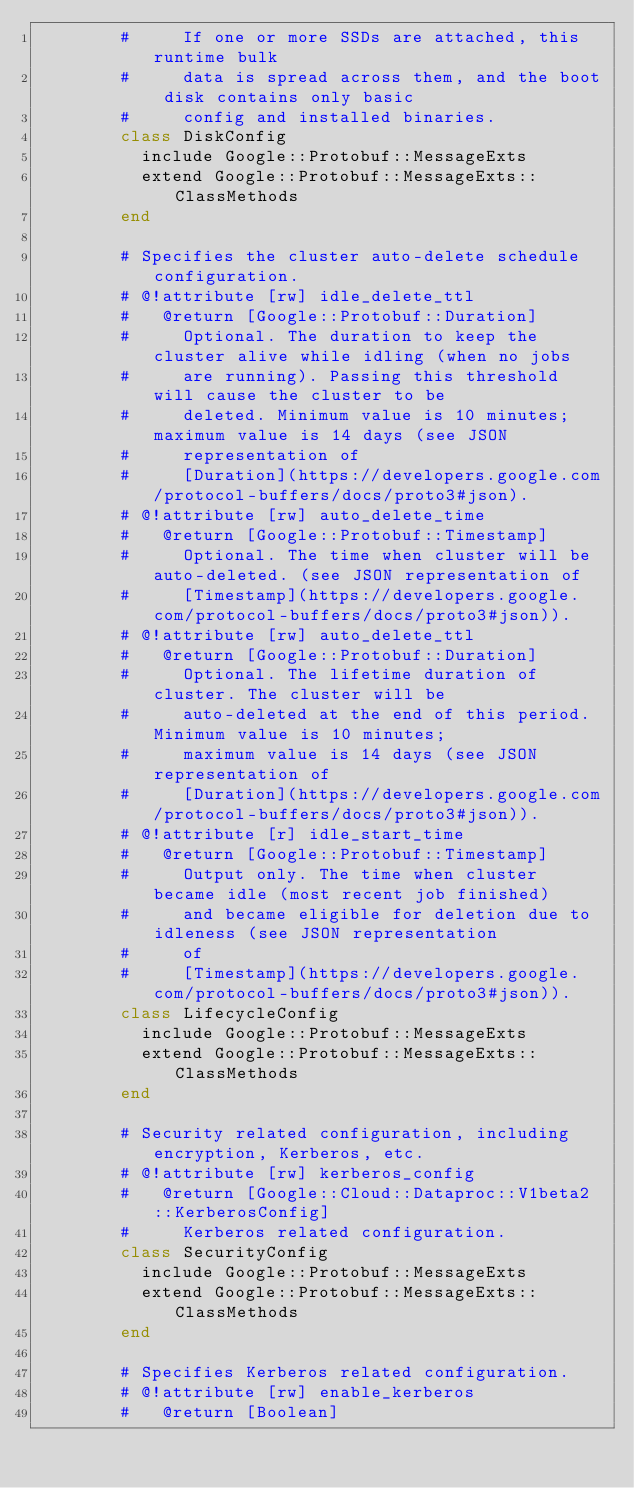<code> <loc_0><loc_0><loc_500><loc_500><_Ruby_>        #     If one or more SSDs are attached, this runtime bulk
        #     data is spread across them, and the boot disk contains only basic
        #     config and installed binaries.
        class DiskConfig
          include Google::Protobuf::MessageExts
          extend Google::Protobuf::MessageExts::ClassMethods
        end

        # Specifies the cluster auto-delete schedule configuration.
        # @!attribute [rw] idle_delete_ttl
        #   @return [Google::Protobuf::Duration]
        #     Optional. The duration to keep the cluster alive while idling (when no jobs
        #     are running). Passing this threshold will cause the cluster to be
        #     deleted. Minimum value is 10 minutes; maximum value is 14 days (see JSON
        #     representation of
        #     [Duration](https://developers.google.com/protocol-buffers/docs/proto3#json).
        # @!attribute [rw] auto_delete_time
        #   @return [Google::Protobuf::Timestamp]
        #     Optional. The time when cluster will be auto-deleted. (see JSON representation of
        #     [Timestamp](https://developers.google.com/protocol-buffers/docs/proto3#json)).
        # @!attribute [rw] auto_delete_ttl
        #   @return [Google::Protobuf::Duration]
        #     Optional. The lifetime duration of cluster. The cluster will be
        #     auto-deleted at the end of this period. Minimum value is 10 minutes;
        #     maximum value is 14 days (see JSON representation of
        #     [Duration](https://developers.google.com/protocol-buffers/docs/proto3#json)).
        # @!attribute [r] idle_start_time
        #   @return [Google::Protobuf::Timestamp]
        #     Output only. The time when cluster became idle (most recent job finished)
        #     and became eligible for deletion due to idleness (see JSON representation
        #     of
        #     [Timestamp](https://developers.google.com/protocol-buffers/docs/proto3#json)).
        class LifecycleConfig
          include Google::Protobuf::MessageExts
          extend Google::Protobuf::MessageExts::ClassMethods
        end

        # Security related configuration, including encryption, Kerberos, etc.
        # @!attribute [rw] kerberos_config
        #   @return [Google::Cloud::Dataproc::V1beta2::KerberosConfig]
        #     Kerberos related configuration.
        class SecurityConfig
          include Google::Protobuf::MessageExts
          extend Google::Protobuf::MessageExts::ClassMethods
        end

        # Specifies Kerberos related configuration.
        # @!attribute [rw] enable_kerberos
        #   @return [Boolean]</code> 